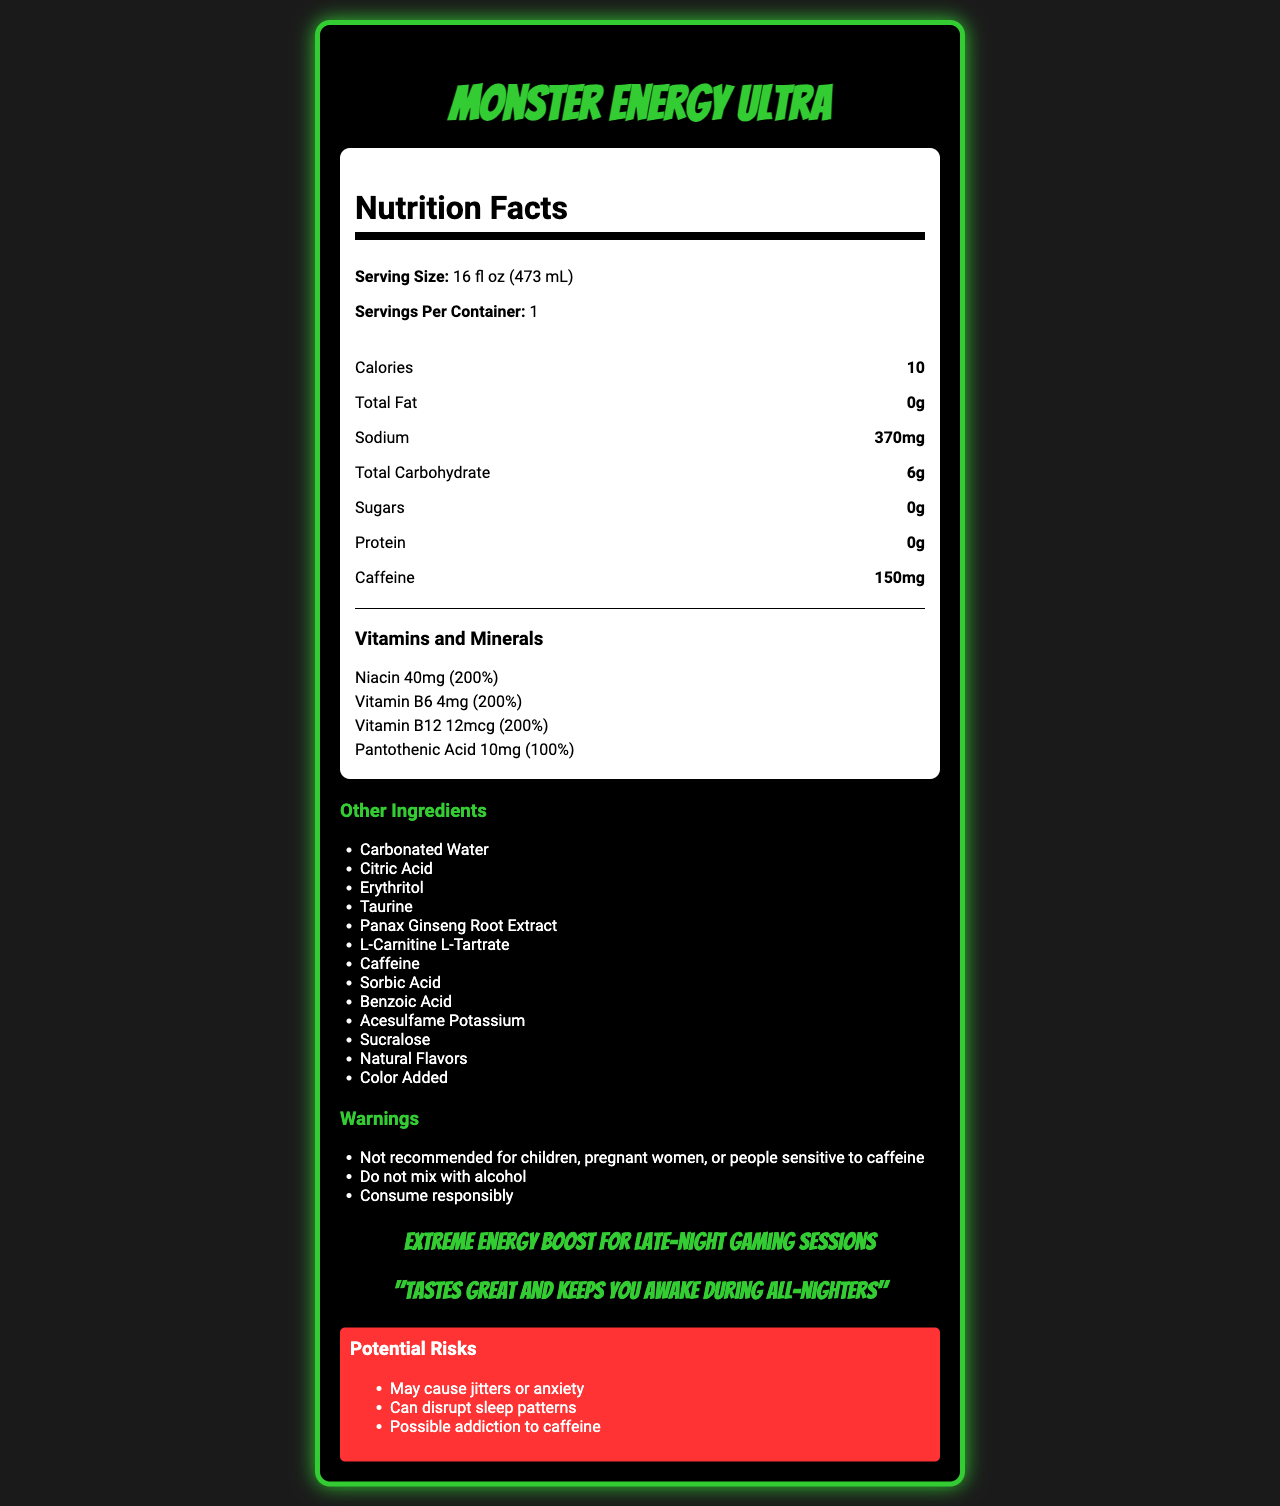what is the serving size of Monster Energy Ultra? The document states that the serving size is 16 fl oz (473 mL).
Answer: 16 fl oz (473 mL) how many calories are in one serving of Monster Energy Ultra? The document lists 10 calories under the "Nutrition Facts" section.
Answer: 10 what is the amount of caffeine per serving? The document specifies that there are 150mg of caffeine per serving.
Answer: 150mg what are the amounts of Vitamin B6 and Niacin in Monster Energy Ultra? The document indicates that Vitamin B6 is 4mg and Niacin is 40mg in the "Vitamins and Minerals" section.
Answer: Vitamin B6: 4mg, Niacin: 40mg what warnings are associated with Monster Energy Ultra? The document includes these warnings under the "Warnings" section.
Answer: Not recommended for children, pregnant women, or people sensitive to caffeine; Do not mix with alcohol; Consume responsibly how much sodium is in one serving of Monster Energy Ultra? A. 200mg B. 300mg C. 370mg D. 500mg The document lists 370mg of sodium.
Answer: C which of the following is NOT an ingredient in Monster Energy Ultra? A. Carbonated Water B. Citric Acid C. High Fructose Corn Syrup D. Taurine The document lists the ingredients, and High Fructose Corn Syrup is not one of them.
Answer: C is Monster Energy Ultra recommended for children? The document clearly states that it is "Not recommended for children" in the warnings section.
Answer: No summarize the main features and purpose of Monster Energy Ultra The document details the nutritional facts, ingredients, warnings, and potential risks of Monster Energy Ultra, emphasizing that it's meant for a strong energy boost but advises caution due to its high caffeine content and associated risks.
Answer: Monster Energy Ultra is a high-caffeine energy drink providing 150mg of caffeine per serving and contains various vitamins like Niacin, Vitamin B6, Vitamin B12, and Pantothenic Acid. It's intended for an extreme energy boost, particularly for activities like late-night gaming sessions. However, it comes with warnings for children, pregnant women, and people sensitive to caffeine, and has potential risks such as causing jitters, disrupting sleep patterns, and possible addiction to caffeine. what is the flavoring used in Monster Energy Ultra? The document lists "Natural Flavors" as an ingredient but does not specify the exact flavors used.
Answer: Cannot be determined what percentage of the daily value of Vitamin B12 does this drink provide? The document states that the drink provides 200% of the daily value for Vitamin B12.
Answer: 200% 